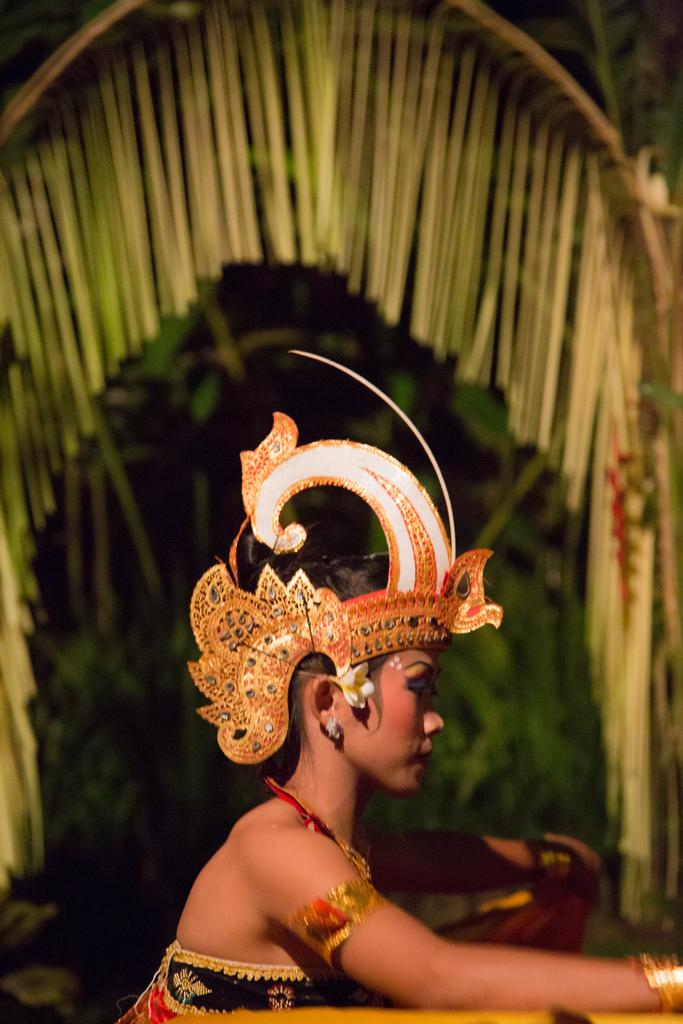Who is present in the image? There is a woman in the image. What is the woman wearing on her head? The woman is wearing a design cap. Where is the cap located in the image? The cap is visible at the bottom of the image. What natural element can be seen in the image? There is a tree visible at the top of the image. What type of animal can be seen at the zoo in the image? There is no zoo or animal present in the image; it features a woman wearing a design cap and a tree visible at the top. 